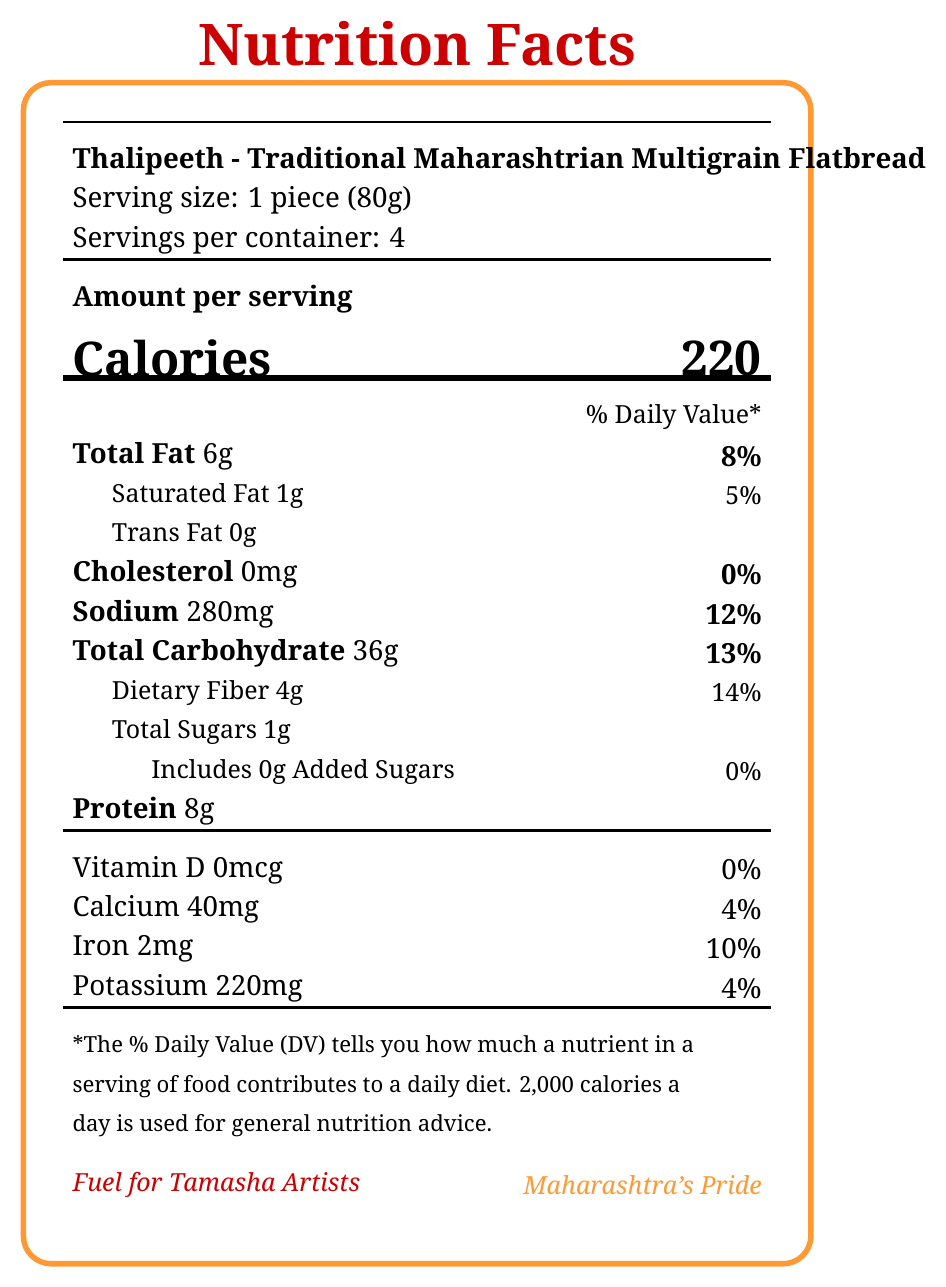What is the serving size for Thalipeeth? The serving size is clearly indicated as "1 piece (80g)" in the document.
Answer: 1 piece (80g) How many calories are there in one serving of Thalipeeth? The document specifies that one serving of Thalipeeth contains 220 calories.
Answer: 220 What is the daily value percentage of total fat in Thalipeeth? The % Daily Value for total fat is listed as 8%.
Answer: 8% How much protein is in one serving of Thalipeeth? The amount of protein per serving is mentioned as 8 grams.
Answer: 8 grams Which ingredient in Thalipeeth might be a concern for people with gluten intolerance? The document lists 'Contains wheat’ under allergens, indicating wheat flour as a potential concern for gluten intolerance.
Answer: Wheat flour How much dietary fiber does Thalipeeth provide per serving? A. 2g B. 4g C. 6g D. 8g The document indicates that Thalipeeth contains 4 grams of dietary fiber per serving.
Answer: B. 4g What percentage of the daily iron requirement does one serving of Thalipeeth provide? A. 2% B. 4% C. 10% D. 25% The % Daily Value for iron is listed as 10%.
Answer: C. 10% Does Thalipeeth contain any trans fat? The document states that the amount of trans fat is 0 grams.
Answer: No True or False: Thalipeeth has added sugars. The document mentions that there are 0 grams of added sugars.
Answer: False What is the main idea of the document? The document details the nutritional content, ingredient list, and cultural significance of Thalipeeth, particularly emphasizing its benefits for Tamasha artists.
Answer: The document provides the nutrition facts for Thalipeeth, a traditional Maharashtrian multigrain flatbread, including its serving size, calorie content, and nutrient information, along with details about its benefits and cultural significance to Tamasha artists. How many grams of calcium are present in one serving of Thalipeeth? The document does not convert the milligrams of calcium into grams, and thus, it cannot be answered directly.
Answer: Not enough information 